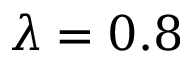Convert formula to latex. <formula><loc_0><loc_0><loc_500><loc_500>\lambda = 0 . 8</formula> 